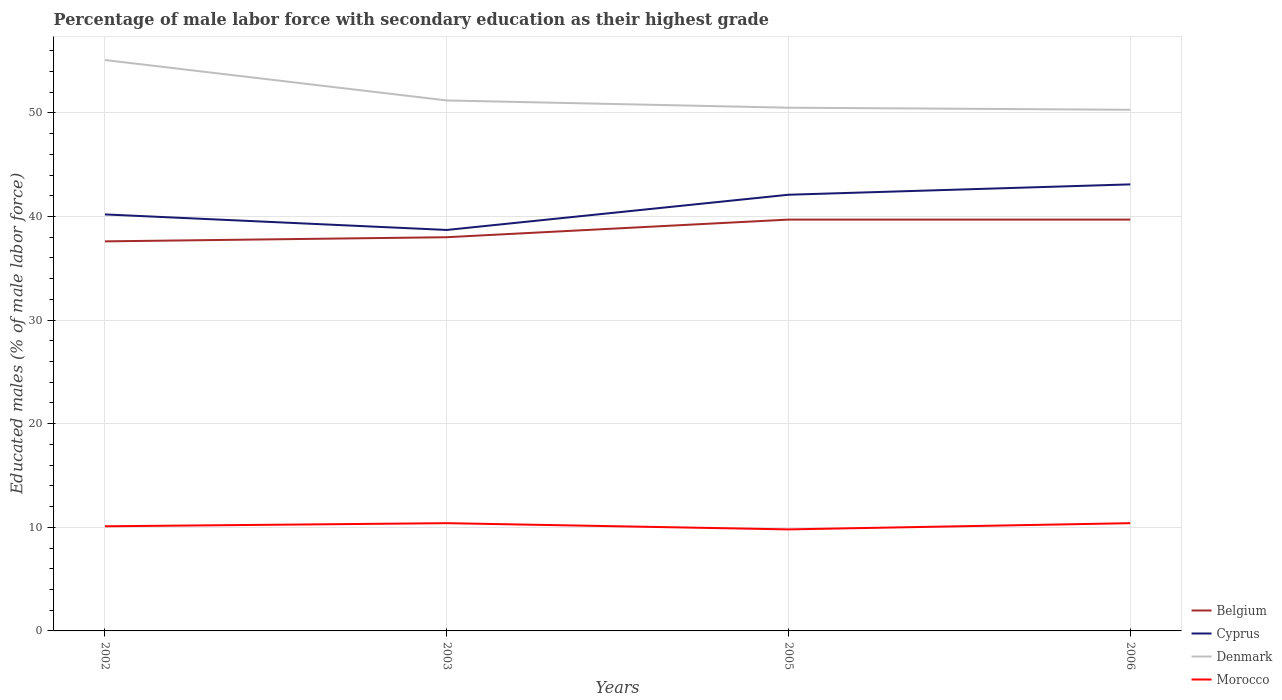How many different coloured lines are there?
Make the answer very short. 4. Does the line corresponding to Cyprus intersect with the line corresponding to Morocco?
Make the answer very short. No. Across all years, what is the maximum percentage of male labor force with secondary education in Morocco?
Provide a short and direct response. 9.8. In which year was the percentage of male labor force with secondary education in Belgium maximum?
Keep it short and to the point. 2002. What is the total percentage of male labor force with secondary education in Denmark in the graph?
Offer a terse response. 3.9. What is the difference between the highest and the second highest percentage of male labor force with secondary education in Morocco?
Ensure brevity in your answer.  0.6. How many years are there in the graph?
Provide a succinct answer. 4. What is the difference between two consecutive major ticks on the Y-axis?
Give a very brief answer. 10. Does the graph contain any zero values?
Your response must be concise. No. Does the graph contain grids?
Your response must be concise. Yes. Where does the legend appear in the graph?
Keep it short and to the point. Bottom right. What is the title of the graph?
Give a very brief answer. Percentage of male labor force with secondary education as their highest grade. Does "Israel" appear as one of the legend labels in the graph?
Make the answer very short. No. What is the label or title of the Y-axis?
Ensure brevity in your answer.  Educated males (% of male labor force). What is the Educated males (% of male labor force) in Belgium in 2002?
Keep it short and to the point. 37.6. What is the Educated males (% of male labor force) in Cyprus in 2002?
Your answer should be very brief. 40.2. What is the Educated males (% of male labor force) of Denmark in 2002?
Keep it short and to the point. 55.1. What is the Educated males (% of male labor force) in Morocco in 2002?
Ensure brevity in your answer.  10.1. What is the Educated males (% of male labor force) in Cyprus in 2003?
Provide a short and direct response. 38.7. What is the Educated males (% of male labor force) in Denmark in 2003?
Your answer should be compact. 51.2. What is the Educated males (% of male labor force) in Morocco in 2003?
Give a very brief answer. 10.4. What is the Educated males (% of male labor force) of Belgium in 2005?
Make the answer very short. 39.7. What is the Educated males (% of male labor force) in Cyprus in 2005?
Your answer should be compact. 42.1. What is the Educated males (% of male labor force) in Denmark in 2005?
Your response must be concise. 50.5. What is the Educated males (% of male labor force) of Morocco in 2005?
Your response must be concise. 9.8. What is the Educated males (% of male labor force) of Belgium in 2006?
Ensure brevity in your answer.  39.7. What is the Educated males (% of male labor force) in Cyprus in 2006?
Your answer should be very brief. 43.1. What is the Educated males (% of male labor force) in Denmark in 2006?
Offer a terse response. 50.3. What is the Educated males (% of male labor force) of Morocco in 2006?
Ensure brevity in your answer.  10.4. Across all years, what is the maximum Educated males (% of male labor force) in Belgium?
Your answer should be compact. 39.7. Across all years, what is the maximum Educated males (% of male labor force) in Cyprus?
Your answer should be very brief. 43.1. Across all years, what is the maximum Educated males (% of male labor force) in Denmark?
Offer a terse response. 55.1. Across all years, what is the maximum Educated males (% of male labor force) in Morocco?
Offer a terse response. 10.4. Across all years, what is the minimum Educated males (% of male labor force) of Belgium?
Ensure brevity in your answer.  37.6. Across all years, what is the minimum Educated males (% of male labor force) in Cyprus?
Your answer should be compact. 38.7. Across all years, what is the minimum Educated males (% of male labor force) in Denmark?
Your answer should be very brief. 50.3. Across all years, what is the minimum Educated males (% of male labor force) of Morocco?
Provide a short and direct response. 9.8. What is the total Educated males (% of male labor force) in Belgium in the graph?
Your response must be concise. 155. What is the total Educated males (% of male labor force) of Cyprus in the graph?
Your answer should be very brief. 164.1. What is the total Educated males (% of male labor force) of Denmark in the graph?
Keep it short and to the point. 207.1. What is the total Educated males (% of male labor force) in Morocco in the graph?
Keep it short and to the point. 40.7. What is the difference between the Educated males (% of male labor force) of Denmark in 2002 and that in 2003?
Offer a terse response. 3.9. What is the difference between the Educated males (% of male labor force) in Belgium in 2002 and that in 2006?
Your answer should be very brief. -2.1. What is the difference between the Educated males (% of male labor force) of Cyprus in 2003 and that in 2005?
Provide a short and direct response. -3.4. What is the difference between the Educated males (% of male labor force) of Morocco in 2003 and that in 2005?
Ensure brevity in your answer.  0.6. What is the difference between the Educated males (% of male labor force) in Belgium in 2003 and that in 2006?
Ensure brevity in your answer.  -1.7. What is the difference between the Educated males (% of male labor force) in Cyprus in 2003 and that in 2006?
Your answer should be very brief. -4.4. What is the difference between the Educated males (% of male labor force) of Denmark in 2003 and that in 2006?
Give a very brief answer. 0.9. What is the difference between the Educated males (% of male labor force) in Morocco in 2003 and that in 2006?
Your response must be concise. 0. What is the difference between the Educated males (% of male labor force) in Cyprus in 2005 and that in 2006?
Your answer should be very brief. -1. What is the difference between the Educated males (% of male labor force) in Denmark in 2005 and that in 2006?
Your response must be concise. 0.2. What is the difference between the Educated males (% of male labor force) in Belgium in 2002 and the Educated males (% of male labor force) in Morocco in 2003?
Offer a very short reply. 27.2. What is the difference between the Educated males (% of male labor force) of Cyprus in 2002 and the Educated males (% of male labor force) of Morocco in 2003?
Make the answer very short. 29.8. What is the difference between the Educated males (% of male labor force) in Denmark in 2002 and the Educated males (% of male labor force) in Morocco in 2003?
Provide a succinct answer. 44.7. What is the difference between the Educated males (% of male labor force) in Belgium in 2002 and the Educated males (% of male labor force) in Cyprus in 2005?
Your answer should be very brief. -4.5. What is the difference between the Educated males (% of male labor force) in Belgium in 2002 and the Educated males (% of male labor force) in Morocco in 2005?
Ensure brevity in your answer.  27.8. What is the difference between the Educated males (% of male labor force) in Cyprus in 2002 and the Educated males (% of male labor force) in Morocco in 2005?
Make the answer very short. 30.4. What is the difference between the Educated males (% of male labor force) in Denmark in 2002 and the Educated males (% of male labor force) in Morocco in 2005?
Offer a very short reply. 45.3. What is the difference between the Educated males (% of male labor force) of Belgium in 2002 and the Educated males (% of male labor force) of Cyprus in 2006?
Your response must be concise. -5.5. What is the difference between the Educated males (% of male labor force) in Belgium in 2002 and the Educated males (% of male labor force) in Morocco in 2006?
Your response must be concise. 27.2. What is the difference between the Educated males (% of male labor force) of Cyprus in 2002 and the Educated males (% of male labor force) of Morocco in 2006?
Your answer should be compact. 29.8. What is the difference between the Educated males (% of male labor force) of Denmark in 2002 and the Educated males (% of male labor force) of Morocco in 2006?
Offer a terse response. 44.7. What is the difference between the Educated males (% of male labor force) in Belgium in 2003 and the Educated males (% of male labor force) in Morocco in 2005?
Give a very brief answer. 28.2. What is the difference between the Educated males (% of male labor force) in Cyprus in 2003 and the Educated males (% of male labor force) in Denmark in 2005?
Provide a short and direct response. -11.8. What is the difference between the Educated males (% of male labor force) of Cyprus in 2003 and the Educated males (% of male labor force) of Morocco in 2005?
Keep it short and to the point. 28.9. What is the difference between the Educated males (% of male labor force) in Denmark in 2003 and the Educated males (% of male labor force) in Morocco in 2005?
Offer a terse response. 41.4. What is the difference between the Educated males (% of male labor force) in Belgium in 2003 and the Educated males (% of male labor force) in Cyprus in 2006?
Your answer should be compact. -5.1. What is the difference between the Educated males (% of male labor force) of Belgium in 2003 and the Educated males (% of male labor force) of Morocco in 2006?
Make the answer very short. 27.6. What is the difference between the Educated males (% of male labor force) of Cyprus in 2003 and the Educated males (% of male labor force) of Morocco in 2006?
Your answer should be compact. 28.3. What is the difference between the Educated males (% of male labor force) of Denmark in 2003 and the Educated males (% of male labor force) of Morocco in 2006?
Your response must be concise. 40.8. What is the difference between the Educated males (% of male labor force) in Belgium in 2005 and the Educated males (% of male labor force) in Cyprus in 2006?
Make the answer very short. -3.4. What is the difference between the Educated males (% of male labor force) of Belgium in 2005 and the Educated males (% of male labor force) of Denmark in 2006?
Offer a terse response. -10.6. What is the difference between the Educated males (% of male labor force) of Belgium in 2005 and the Educated males (% of male labor force) of Morocco in 2006?
Offer a very short reply. 29.3. What is the difference between the Educated males (% of male labor force) in Cyprus in 2005 and the Educated males (% of male labor force) in Denmark in 2006?
Your answer should be compact. -8.2. What is the difference between the Educated males (% of male labor force) in Cyprus in 2005 and the Educated males (% of male labor force) in Morocco in 2006?
Offer a terse response. 31.7. What is the difference between the Educated males (% of male labor force) of Denmark in 2005 and the Educated males (% of male labor force) of Morocco in 2006?
Your answer should be compact. 40.1. What is the average Educated males (% of male labor force) of Belgium per year?
Make the answer very short. 38.75. What is the average Educated males (% of male labor force) of Cyprus per year?
Keep it short and to the point. 41.02. What is the average Educated males (% of male labor force) of Denmark per year?
Provide a short and direct response. 51.77. What is the average Educated males (% of male labor force) of Morocco per year?
Keep it short and to the point. 10.18. In the year 2002, what is the difference between the Educated males (% of male labor force) of Belgium and Educated males (% of male labor force) of Denmark?
Your answer should be very brief. -17.5. In the year 2002, what is the difference between the Educated males (% of male labor force) of Belgium and Educated males (% of male labor force) of Morocco?
Make the answer very short. 27.5. In the year 2002, what is the difference between the Educated males (% of male labor force) in Cyprus and Educated males (% of male labor force) in Denmark?
Your answer should be very brief. -14.9. In the year 2002, what is the difference between the Educated males (% of male labor force) of Cyprus and Educated males (% of male labor force) of Morocco?
Your answer should be compact. 30.1. In the year 2003, what is the difference between the Educated males (% of male labor force) in Belgium and Educated males (% of male labor force) in Cyprus?
Provide a succinct answer. -0.7. In the year 2003, what is the difference between the Educated males (% of male labor force) in Belgium and Educated males (% of male labor force) in Denmark?
Make the answer very short. -13.2. In the year 2003, what is the difference between the Educated males (% of male labor force) of Belgium and Educated males (% of male labor force) of Morocco?
Your answer should be compact. 27.6. In the year 2003, what is the difference between the Educated males (% of male labor force) in Cyprus and Educated males (% of male labor force) in Denmark?
Make the answer very short. -12.5. In the year 2003, what is the difference between the Educated males (% of male labor force) of Cyprus and Educated males (% of male labor force) of Morocco?
Offer a terse response. 28.3. In the year 2003, what is the difference between the Educated males (% of male labor force) in Denmark and Educated males (% of male labor force) in Morocco?
Offer a terse response. 40.8. In the year 2005, what is the difference between the Educated males (% of male labor force) of Belgium and Educated males (% of male labor force) of Denmark?
Your answer should be very brief. -10.8. In the year 2005, what is the difference between the Educated males (% of male labor force) in Belgium and Educated males (% of male labor force) in Morocco?
Your response must be concise. 29.9. In the year 2005, what is the difference between the Educated males (% of male labor force) of Cyprus and Educated males (% of male labor force) of Denmark?
Keep it short and to the point. -8.4. In the year 2005, what is the difference between the Educated males (% of male labor force) of Cyprus and Educated males (% of male labor force) of Morocco?
Provide a succinct answer. 32.3. In the year 2005, what is the difference between the Educated males (% of male labor force) in Denmark and Educated males (% of male labor force) in Morocco?
Make the answer very short. 40.7. In the year 2006, what is the difference between the Educated males (% of male labor force) in Belgium and Educated males (% of male labor force) in Cyprus?
Keep it short and to the point. -3.4. In the year 2006, what is the difference between the Educated males (% of male labor force) in Belgium and Educated males (% of male labor force) in Morocco?
Your response must be concise. 29.3. In the year 2006, what is the difference between the Educated males (% of male labor force) in Cyprus and Educated males (% of male labor force) in Denmark?
Ensure brevity in your answer.  -7.2. In the year 2006, what is the difference between the Educated males (% of male labor force) of Cyprus and Educated males (% of male labor force) of Morocco?
Provide a succinct answer. 32.7. In the year 2006, what is the difference between the Educated males (% of male labor force) of Denmark and Educated males (% of male labor force) of Morocco?
Keep it short and to the point. 39.9. What is the ratio of the Educated males (% of male labor force) of Belgium in 2002 to that in 2003?
Provide a succinct answer. 0.99. What is the ratio of the Educated males (% of male labor force) of Cyprus in 2002 to that in 2003?
Provide a succinct answer. 1.04. What is the ratio of the Educated males (% of male labor force) in Denmark in 2002 to that in 2003?
Give a very brief answer. 1.08. What is the ratio of the Educated males (% of male labor force) of Morocco in 2002 to that in 2003?
Your answer should be compact. 0.97. What is the ratio of the Educated males (% of male labor force) in Belgium in 2002 to that in 2005?
Ensure brevity in your answer.  0.95. What is the ratio of the Educated males (% of male labor force) of Cyprus in 2002 to that in 2005?
Offer a very short reply. 0.95. What is the ratio of the Educated males (% of male labor force) of Denmark in 2002 to that in 2005?
Ensure brevity in your answer.  1.09. What is the ratio of the Educated males (% of male labor force) in Morocco in 2002 to that in 2005?
Your answer should be very brief. 1.03. What is the ratio of the Educated males (% of male labor force) in Belgium in 2002 to that in 2006?
Keep it short and to the point. 0.95. What is the ratio of the Educated males (% of male labor force) in Cyprus in 2002 to that in 2006?
Offer a terse response. 0.93. What is the ratio of the Educated males (% of male labor force) of Denmark in 2002 to that in 2006?
Your answer should be compact. 1.1. What is the ratio of the Educated males (% of male labor force) in Morocco in 2002 to that in 2006?
Offer a terse response. 0.97. What is the ratio of the Educated males (% of male labor force) of Belgium in 2003 to that in 2005?
Give a very brief answer. 0.96. What is the ratio of the Educated males (% of male labor force) of Cyprus in 2003 to that in 2005?
Provide a short and direct response. 0.92. What is the ratio of the Educated males (% of male labor force) in Denmark in 2003 to that in 2005?
Provide a succinct answer. 1.01. What is the ratio of the Educated males (% of male labor force) in Morocco in 2003 to that in 2005?
Provide a succinct answer. 1.06. What is the ratio of the Educated males (% of male labor force) of Belgium in 2003 to that in 2006?
Your answer should be compact. 0.96. What is the ratio of the Educated males (% of male labor force) in Cyprus in 2003 to that in 2006?
Your response must be concise. 0.9. What is the ratio of the Educated males (% of male labor force) of Denmark in 2003 to that in 2006?
Ensure brevity in your answer.  1.02. What is the ratio of the Educated males (% of male labor force) of Cyprus in 2005 to that in 2006?
Your response must be concise. 0.98. What is the ratio of the Educated males (% of male labor force) in Morocco in 2005 to that in 2006?
Your answer should be very brief. 0.94. What is the difference between the highest and the second highest Educated males (% of male labor force) of Belgium?
Provide a succinct answer. 0. What is the difference between the highest and the lowest Educated males (% of male labor force) of Denmark?
Keep it short and to the point. 4.8. What is the difference between the highest and the lowest Educated males (% of male labor force) of Morocco?
Your answer should be very brief. 0.6. 